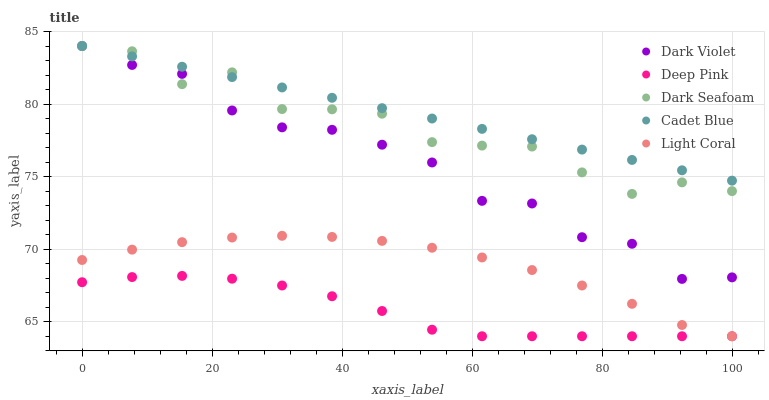Does Deep Pink have the minimum area under the curve?
Answer yes or no. Yes. Does Cadet Blue have the maximum area under the curve?
Answer yes or no. Yes. Does Light Coral have the minimum area under the curve?
Answer yes or no. No. Does Light Coral have the maximum area under the curve?
Answer yes or no. No. Is Cadet Blue the smoothest?
Answer yes or no. Yes. Is Dark Seafoam the roughest?
Answer yes or no. Yes. Is Light Coral the smoothest?
Answer yes or no. No. Is Light Coral the roughest?
Answer yes or no. No. Does Light Coral have the lowest value?
Answer yes or no. Yes. Does Dark Seafoam have the lowest value?
Answer yes or no. No. Does Dark Violet have the highest value?
Answer yes or no. Yes. Does Light Coral have the highest value?
Answer yes or no. No. Is Deep Pink less than Dark Seafoam?
Answer yes or no. Yes. Is Cadet Blue greater than Light Coral?
Answer yes or no. Yes. Does Dark Seafoam intersect Dark Violet?
Answer yes or no. Yes. Is Dark Seafoam less than Dark Violet?
Answer yes or no. No. Is Dark Seafoam greater than Dark Violet?
Answer yes or no. No. Does Deep Pink intersect Dark Seafoam?
Answer yes or no. No. 